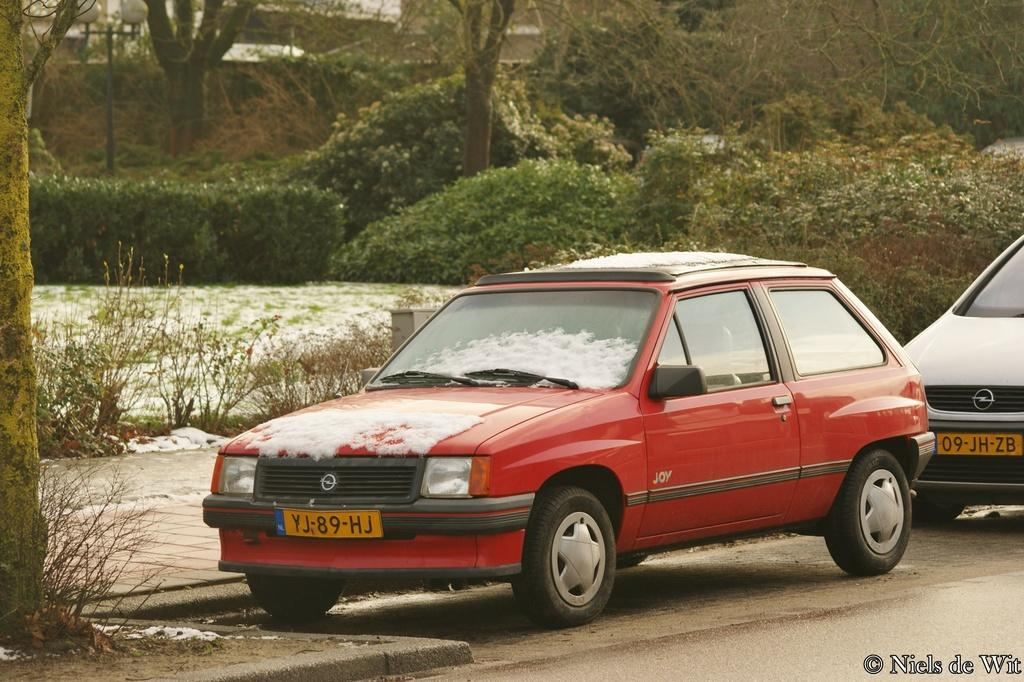<image>
Offer a succinct explanation of the picture presented. A red car with snow on it has a yellow license plate that says YJ 89 HJ. 